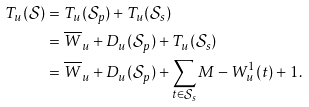Convert formula to latex. <formula><loc_0><loc_0><loc_500><loc_500>T _ { u } ( \mathcal { S } ) & = T _ { u } ( \mathcal { S } _ { p } ) + T _ { u } ( \mathcal { S } _ { s } ) \\ & = \overline { W } _ { u } + D _ { u } ( \mathcal { S } _ { p } ) + T _ { u } ( \mathcal { S } _ { s } ) \\ & = \overline { W } _ { u } + D _ { u } ( \mathcal { S } _ { p } ) + \sum _ { t \in \mathcal { S } _ { s } } M - W _ { u } ^ { 1 } ( t ) + 1 .</formula> 